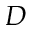<formula> <loc_0><loc_0><loc_500><loc_500>D</formula> 